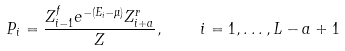Convert formula to latex. <formula><loc_0><loc_0><loc_500><loc_500>P _ { i } = \frac { Z ^ { f } _ { i - 1 } e ^ { - ( E _ { i } - \mu ) } Z ^ { r } _ { i + a } } { Z } , \quad i = 1 , \dots , L - a + 1</formula> 